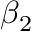Convert formula to latex. <formula><loc_0><loc_0><loc_500><loc_500>\beta _ { 2 }</formula> 